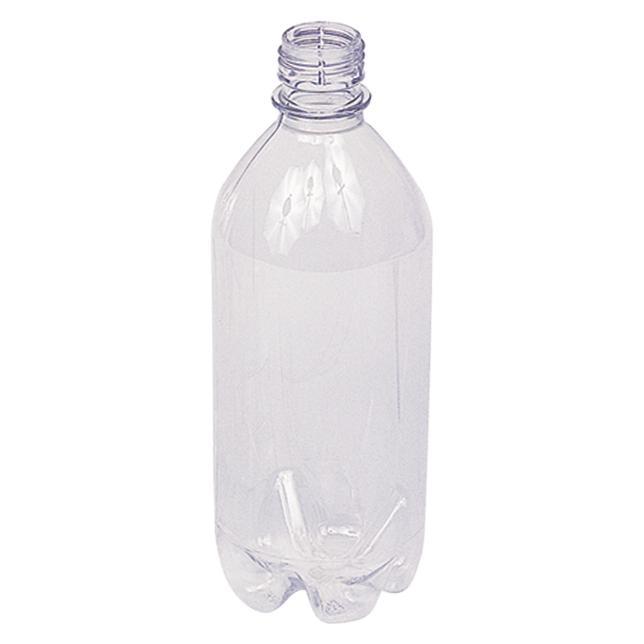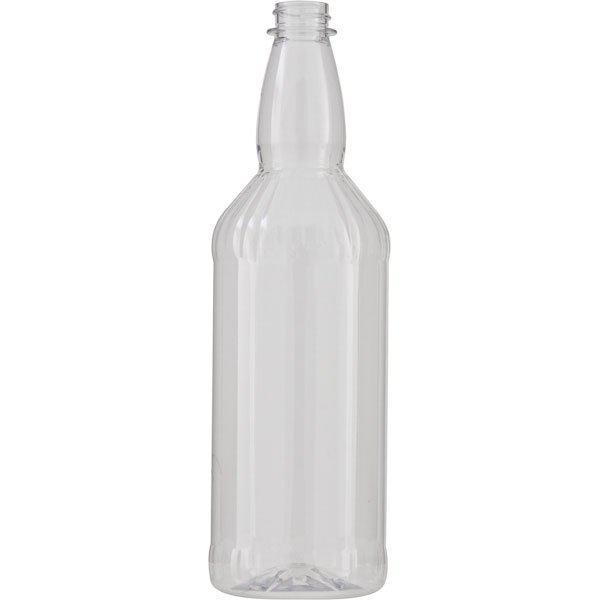The first image is the image on the left, the second image is the image on the right. Assess this claim about the two images: "Each image shows one clear bottle, and the bottle on the left has a white lid on and is mostly cylindrical with at least one ribbed part, while the righthand bottle doesn't have its cap on.". Correct or not? Answer yes or no. No. The first image is the image on the left, the second image is the image on the right. Assess this claim about the two images: "One of the bottles comes with a lid.". Correct or not? Answer yes or no. No. 